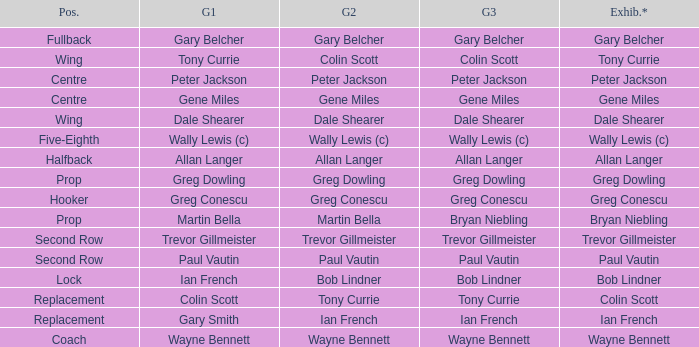What game 1 has halfback as a position? Allan Langer. 